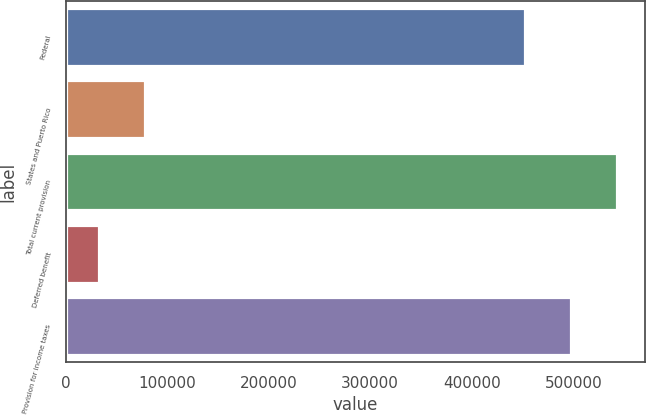Convert chart. <chart><loc_0><loc_0><loc_500><loc_500><bar_chart><fcel>Federal<fcel>States and Puerto Rico<fcel>Total current provision<fcel>Deferred benefit<fcel>Provision for income taxes<nl><fcel>452286<fcel>78297.6<fcel>543409<fcel>32736<fcel>497848<nl></chart> 